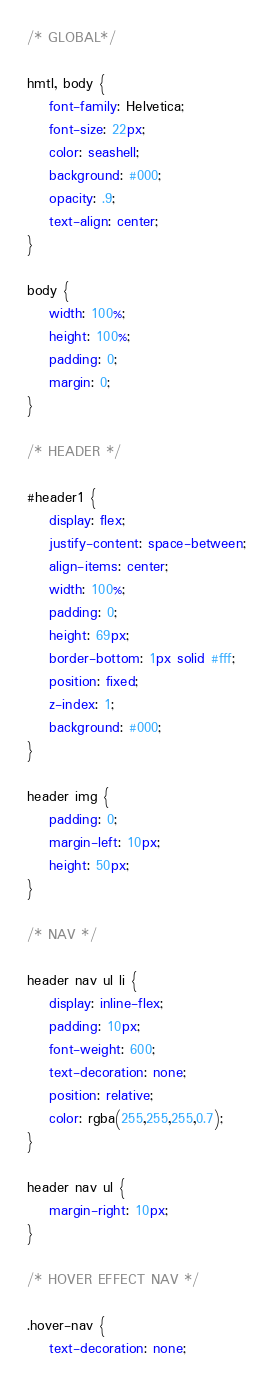<code> <loc_0><loc_0><loc_500><loc_500><_CSS_>/* GLOBAL*/

hmtl, body {
    font-family: Helvetica;
    font-size: 22px;
    color: seashell;
    background: #000;
    opacity: .9;
    text-align: center;
}

body {
    width: 100%;
    height: 100%;
    padding: 0;
    margin: 0;
}

/* HEADER */

#header1 {
    display: flex;
    justify-content: space-between;
    align-items: center;
    width: 100%;
    padding: 0;
    height: 69px;
    border-bottom: 1px solid #fff;
    position: fixed;
    z-index: 1;
    background: #000;
}

header img {
    padding: 0;
    margin-left: 10px;
    height: 50px;
}

/* NAV */

header nav ul li {
    display: inline-flex;
    padding: 10px;
    font-weight: 600;
    text-decoration: none;
    position: relative;
    color: rgba(255,255,255,0.7);
}

header nav ul {
    margin-right: 10px;
}

/* HOVER EFFECT NAV */

.hover-nav {
    text-decoration: none;</code> 